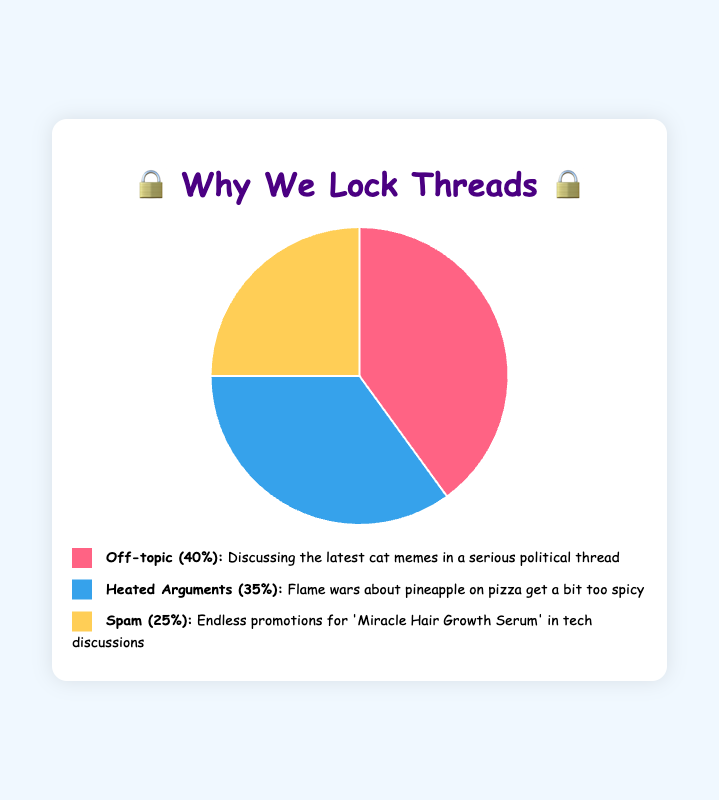Which reason accounts for the largest percentage of thread locking? By looking at the pie chart, "Off-topic" has the largest slice, representing 40% of the reasons.
Answer: Off-topic What's the difference in percentage between Heated Arguments and Spam? "Heated Arguments" has a percentage of 35%, and "Spam" has 25%. The difference is calculated as 35% - 25%.
Answer: 10% Which reasons together account for the majority of thread locking cases? Adding up "Off-topic" (40%) and "Heated Arguments" (35%) gives us 75%, which is more than 50%.
Answer: Off-topic and Heated Arguments If a forum has 100 thread lockings, how many of them are due to spam? Since "Spam" is 25%, we calculate 25% of 100 by multiplying 100 by 0.25.
Answer: 25 Is the percentage of thread lockings due to off-topic discussions greater than those due to heated arguments and spam combined? "Off-topic" is 40%. "Heated Arguments" and "Spam" combined are 35% + 25% = 60%. 40% is not greater than 60%.
Answer: No What color represents the Heated Arguments section in the pie chart? By referring to the visual legend below the pie chart, "Heated Arguments" is represented by the blue color.
Answer: Blue What is the total percentage of thread lockings due to either off-topic discussions or spam? Adding "Off-topic" (40%) and "Spam" (25%) gives a total of 65%.
Answer: 65% Which section appears smaller, Heated Arguments or Spam? By comparing the sizes of the slices, "Spam" at 25% appears smaller than "Heated Arguments" at 35%.
Answer: Spam Calculate the average percentage of thread lockings for all three reasons. Summing up the percentages for "Off-topic" (40%), "Heated Arguments" (35%), and "Spam" (25%) gives 100%. The average is calculated by dividing 100 by 3.
Answer: 33.33% What is the second most common reason for thread locking? By comparing percentages, "Heated Arguments" at 35% is the second largest after "Off-topic."
Answer: Heated Arguments 